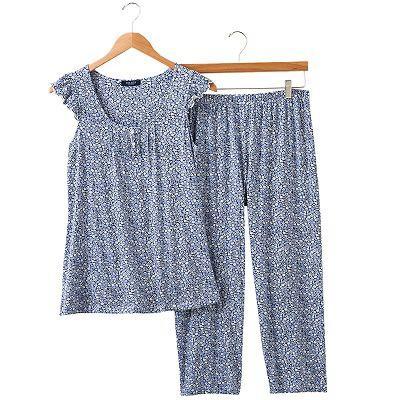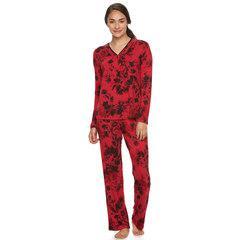The first image is the image on the left, the second image is the image on the right. For the images displayed, is the sentence "there is a single pair of pajamas with short sleeves and long pants" factually correct? Answer yes or no. Yes. The first image is the image on the left, the second image is the image on the right. Given the left and right images, does the statement "Each image contains one sleepwear outfit consisting of a patterned top and matching pants, but one outfit has long sleeves while the other has short ruffled sleeves." hold true? Answer yes or no. Yes. 